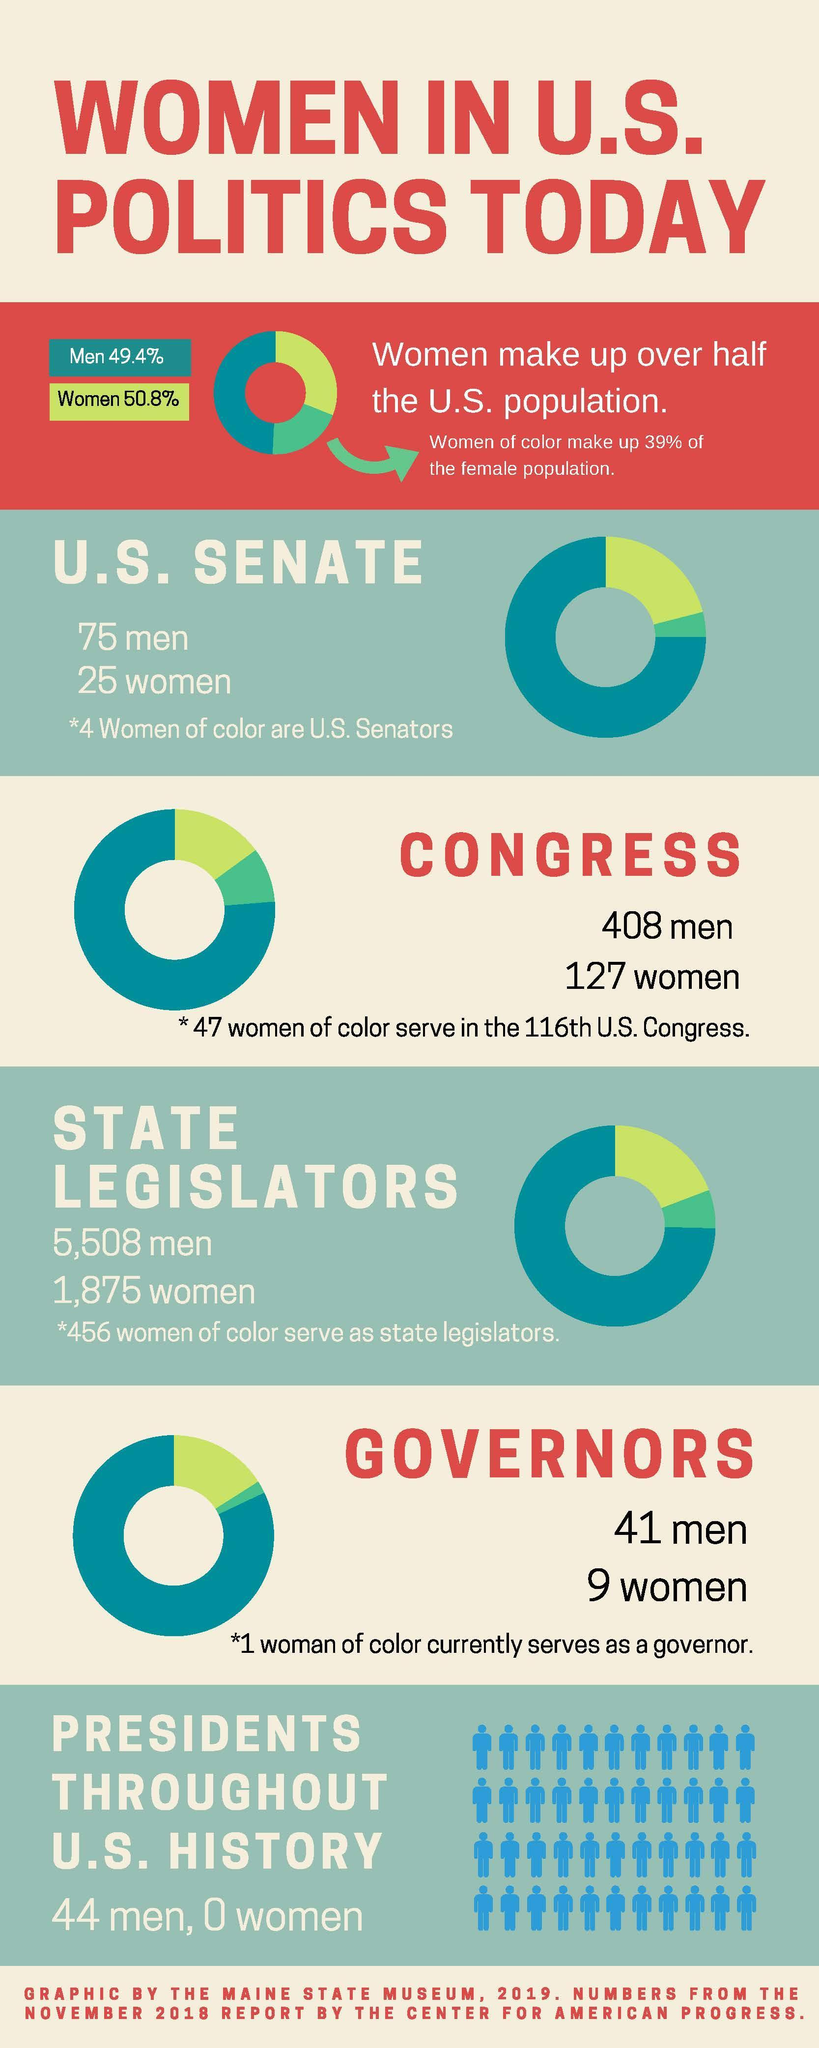How many US governors are women as of November 2018?
Answer the question with a short phrase. 9 How many women are in the U.S. Senate as of November 2018? 25 for which position in US politics, there has been no woman representative president What % of the US Senate are women 25 What is the total number of state legislators 7383 How many men served as a state legislator in the U.S as of November 2018? 5,508 